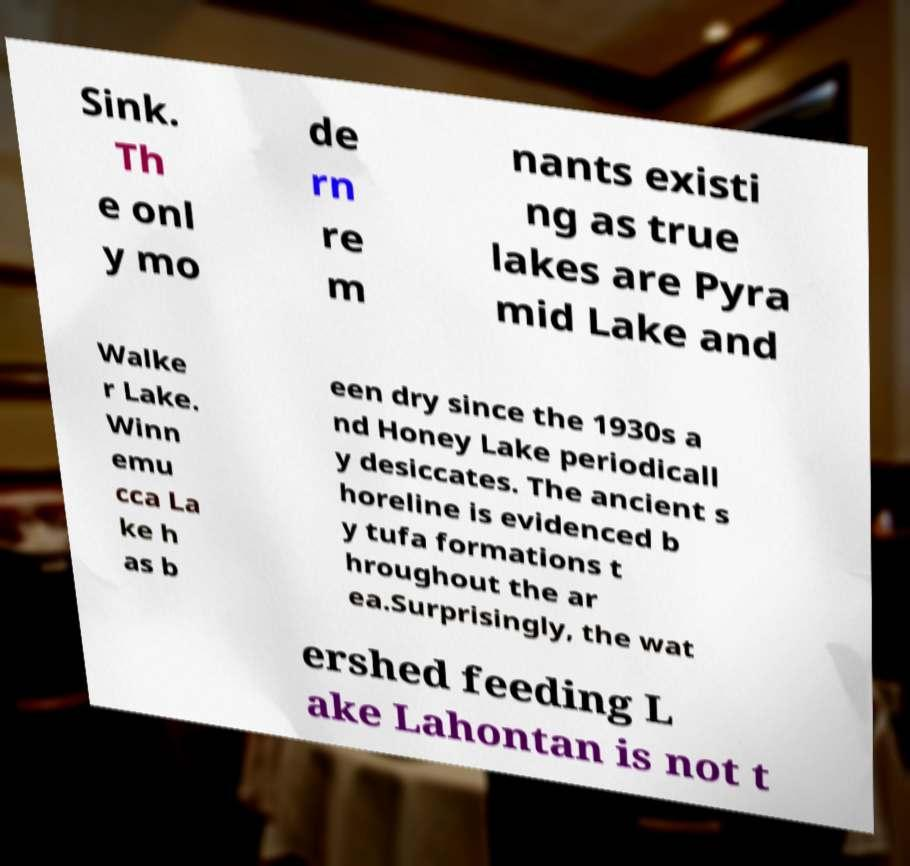Can you read and provide the text displayed in the image?This photo seems to have some interesting text. Can you extract and type it out for me? Sink. Th e onl y mo de rn re m nants existi ng as true lakes are Pyra mid Lake and Walke r Lake. Winn emu cca La ke h as b een dry since the 1930s a nd Honey Lake periodicall y desiccates. The ancient s horeline is evidenced b y tufa formations t hroughout the ar ea.Surprisingly, the wat ershed feeding L ake Lahontan is not t 